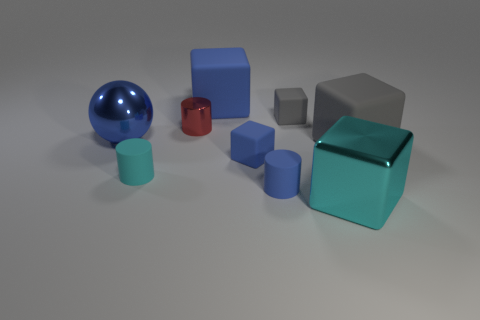Does the object that is right of the shiny cube have the same size as the gray thing on the left side of the big metallic cube? Upon examining the image, the object to the right of the shiny cube, which appears to be a matte blue cube, does not have the same size as the gray object to the left of the large metallic cube. The gray object is smaller and less prominent than the blue cube. 